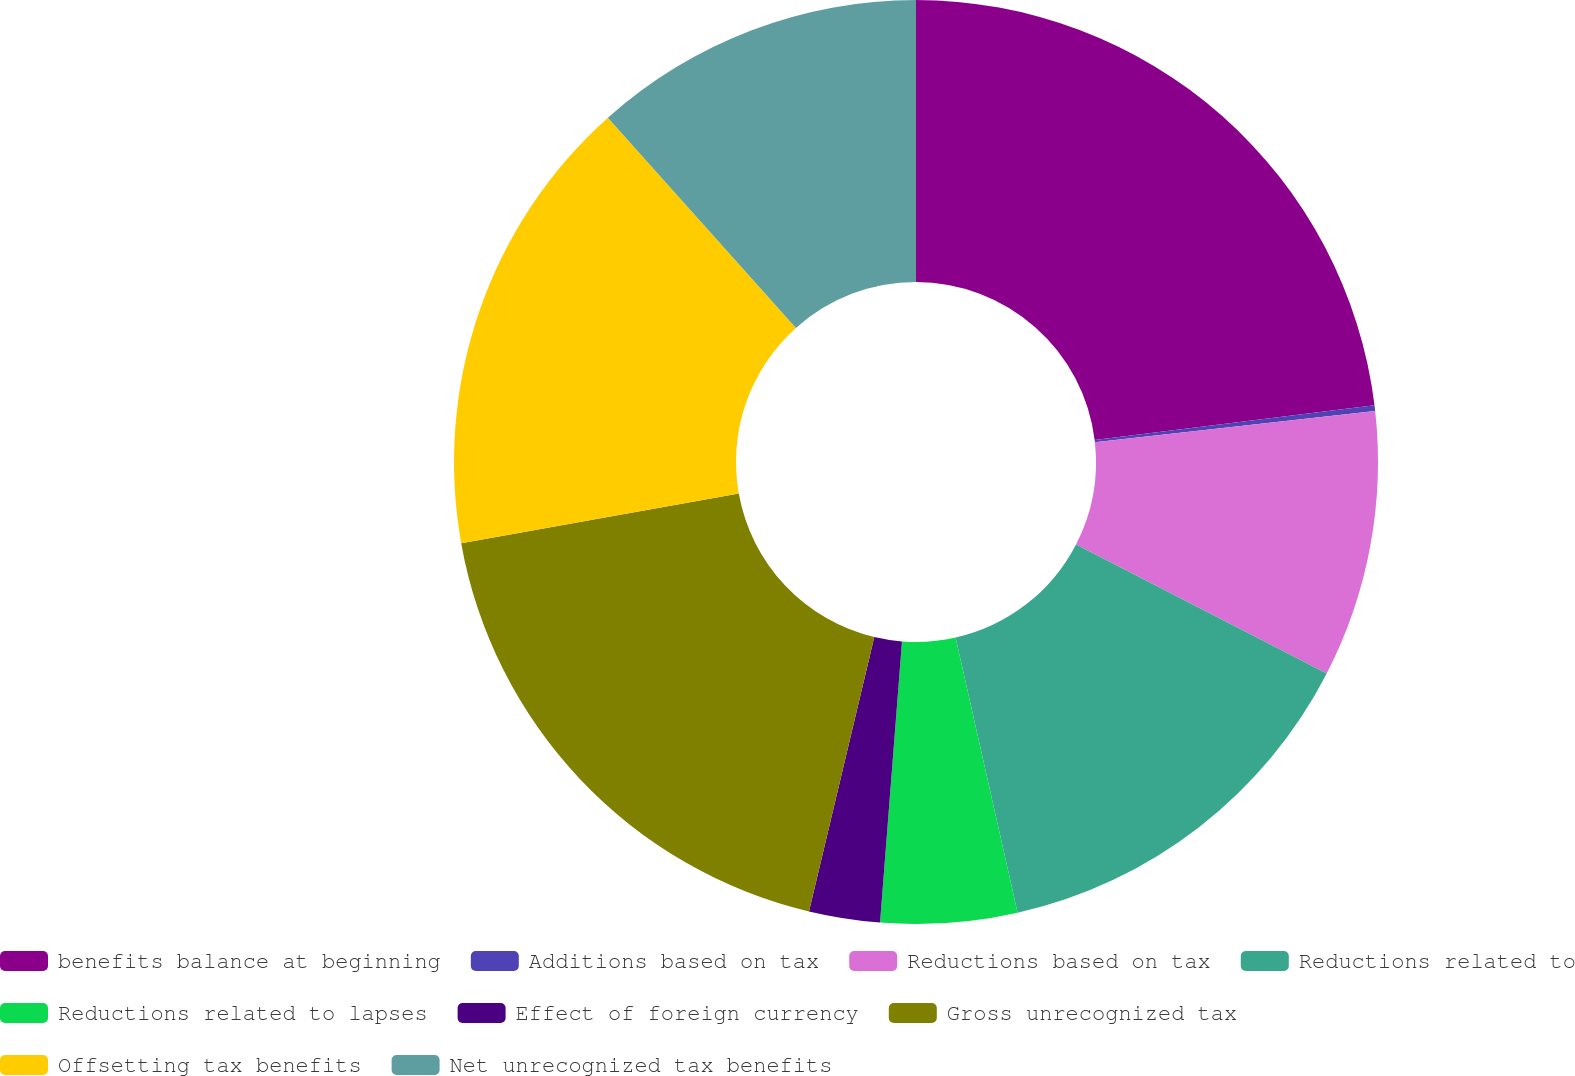Convert chart. <chart><loc_0><loc_0><loc_500><loc_500><pie_chart><fcel>benefits balance at beginning<fcel>Additions based on tax<fcel>Reductions based on tax<fcel>Reductions related to<fcel>Reductions related to lapses<fcel>Effect of foreign currency<fcel>Gross unrecognized tax<fcel>Offsetting tax benefits<fcel>Net unrecognized tax benefits<nl><fcel>23.04%<fcel>0.2%<fcel>9.33%<fcel>13.9%<fcel>4.77%<fcel>2.48%<fcel>18.47%<fcel>16.19%<fcel>11.62%<nl></chart> 